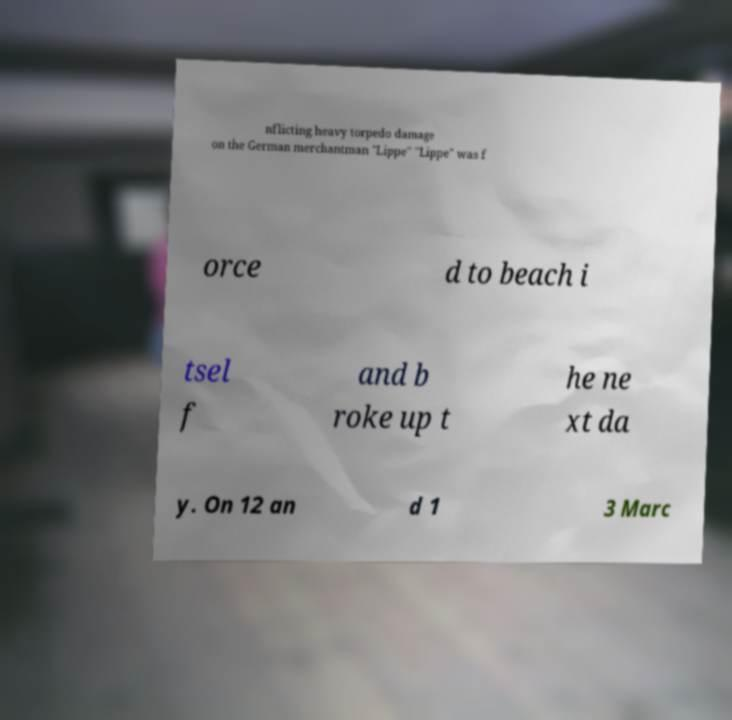I need the written content from this picture converted into text. Can you do that? nflicting heavy torpedo damage on the German merchantman "Lippe" "Lippe" was f orce d to beach i tsel f and b roke up t he ne xt da y. On 12 an d 1 3 Marc 